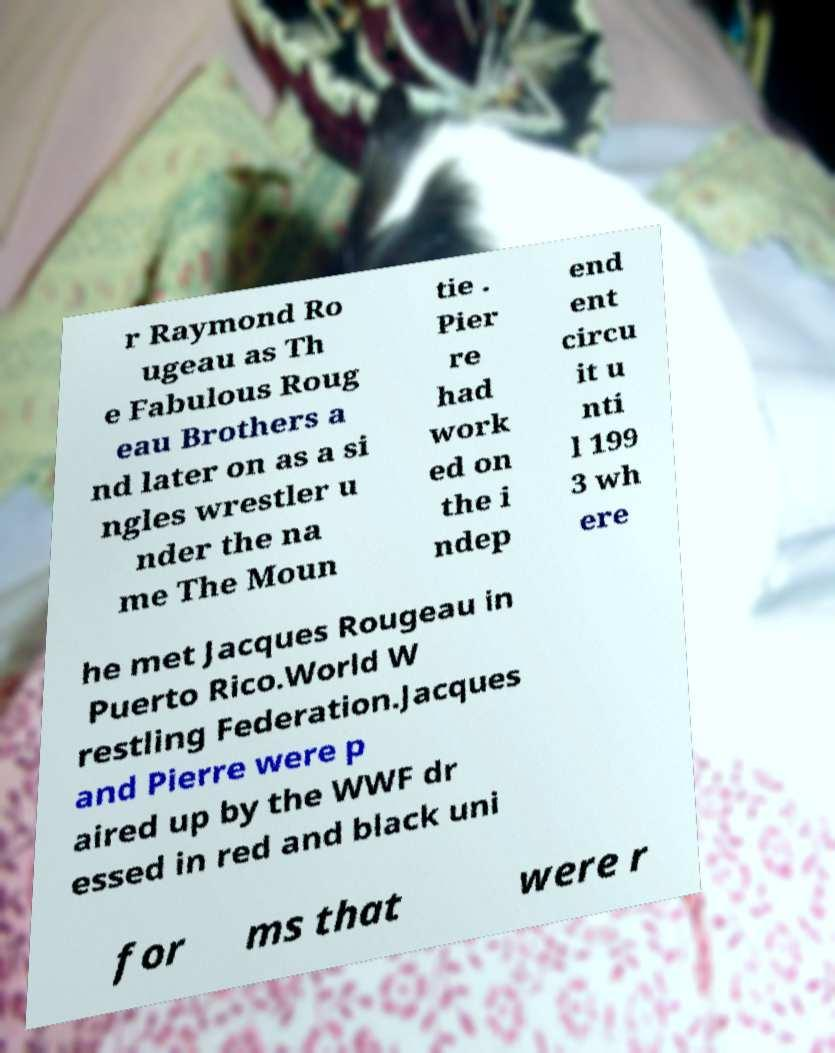Please read and relay the text visible in this image. What does it say? r Raymond Ro ugeau as Th e Fabulous Roug eau Brothers a nd later on as a si ngles wrestler u nder the na me The Moun tie . Pier re had work ed on the i ndep end ent circu it u nti l 199 3 wh ere he met Jacques Rougeau in Puerto Rico.World W restling Federation.Jacques and Pierre were p aired up by the WWF dr essed in red and black uni for ms that were r 